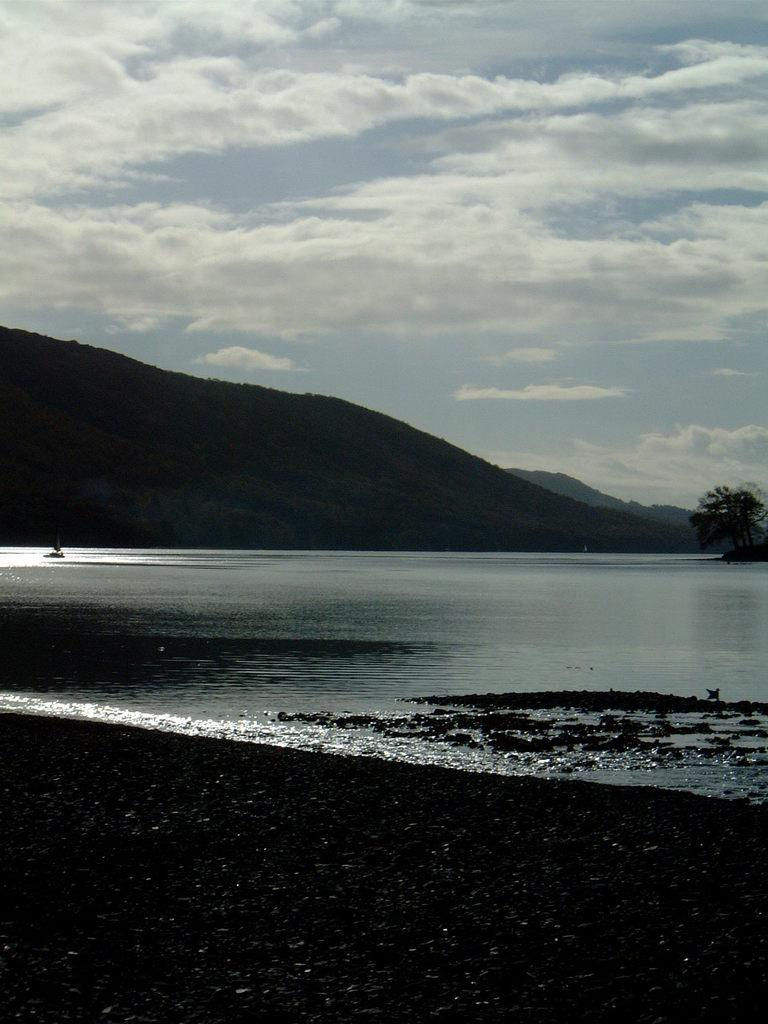What is visible in the image? Water is visible in the image. What can be seen in the background of the image? There are three hills and sky visible in the background of the image. What is the condition of the sky in the image? Clouds are present in the sky. How many sheets are visible in the image? There are no sheets present in the image. Is there a jail visible in the image? There is no jail present in the image. 